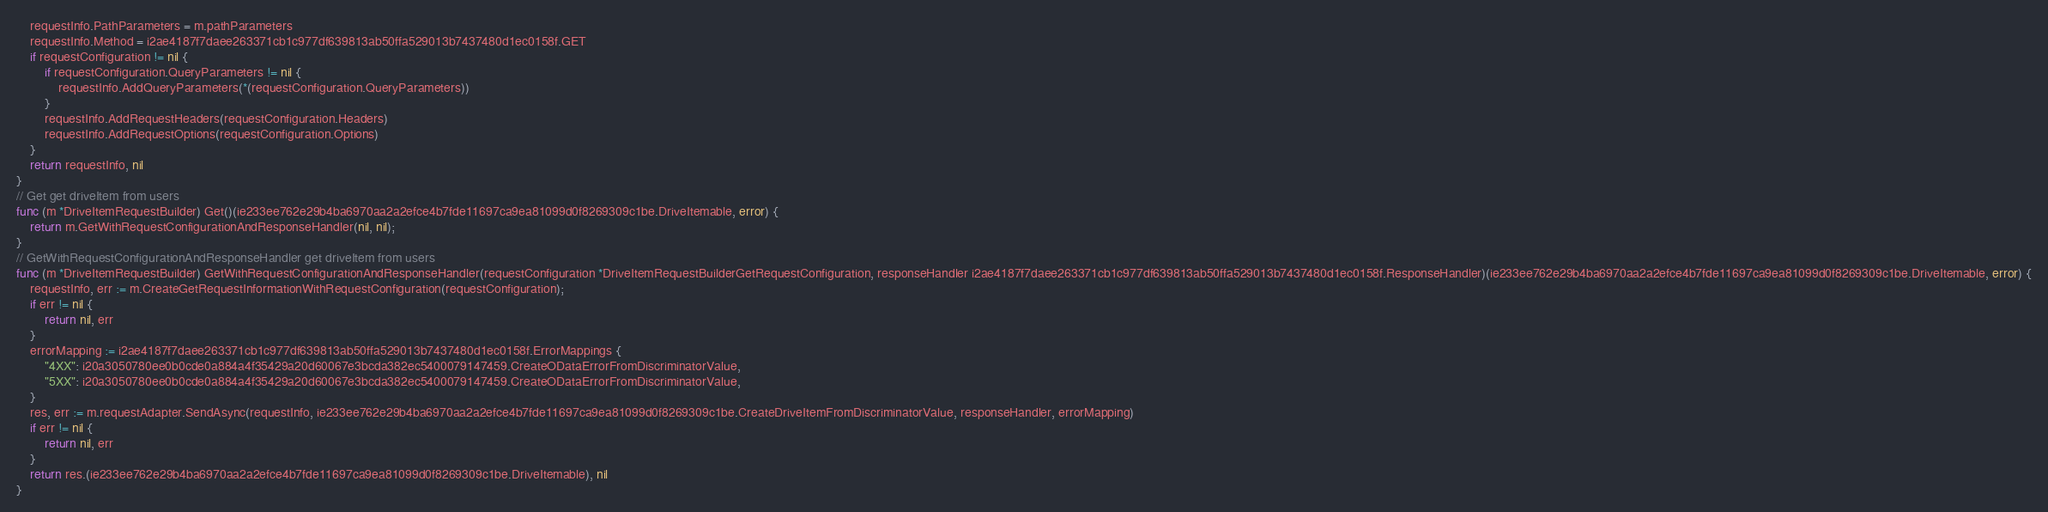Convert code to text. <code><loc_0><loc_0><loc_500><loc_500><_Go_>    requestInfo.PathParameters = m.pathParameters
    requestInfo.Method = i2ae4187f7daee263371cb1c977df639813ab50ffa529013b7437480d1ec0158f.GET
    if requestConfiguration != nil {
        if requestConfiguration.QueryParameters != nil {
            requestInfo.AddQueryParameters(*(requestConfiguration.QueryParameters))
        }
        requestInfo.AddRequestHeaders(requestConfiguration.Headers)
        requestInfo.AddRequestOptions(requestConfiguration.Options)
    }
    return requestInfo, nil
}
// Get get driveItem from users
func (m *DriveItemRequestBuilder) Get()(ie233ee762e29b4ba6970aa2a2efce4b7fde11697ca9ea81099d0f8269309c1be.DriveItemable, error) {
    return m.GetWithRequestConfigurationAndResponseHandler(nil, nil);
}
// GetWithRequestConfigurationAndResponseHandler get driveItem from users
func (m *DriveItemRequestBuilder) GetWithRequestConfigurationAndResponseHandler(requestConfiguration *DriveItemRequestBuilderGetRequestConfiguration, responseHandler i2ae4187f7daee263371cb1c977df639813ab50ffa529013b7437480d1ec0158f.ResponseHandler)(ie233ee762e29b4ba6970aa2a2efce4b7fde11697ca9ea81099d0f8269309c1be.DriveItemable, error) {
    requestInfo, err := m.CreateGetRequestInformationWithRequestConfiguration(requestConfiguration);
    if err != nil {
        return nil, err
    }
    errorMapping := i2ae4187f7daee263371cb1c977df639813ab50ffa529013b7437480d1ec0158f.ErrorMappings {
        "4XX": i20a3050780ee0b0cde0a884a4f35429a20d60067e3bcda382ec5400079147459.CreateODataErrorFromDiscriminatorValue,
        "5XX": i20a3050780ee0b0cde0a884a4f35429a20d60067e3bcda382ec5400079147459.CreateODataErrorFromDiscriminatorValue,
    }
    res, err := m.requestAdapter.SendAsync(requestInfo, ie233ee762e29b4ba6970aa2a2efce4b7fde11697ca9ea81099d0f8269309c1be.CreateDriveItemFromDiscriminatorValue, responseHandler, errorMapping)
    if err != nil {
        return nil, err
    }
    return res.(ie233ee762e29b4ba6970aa2a2efce4b7fde11697ca9ea81099d0f8269309c1be.DriveItemable), nil
}
</code> 